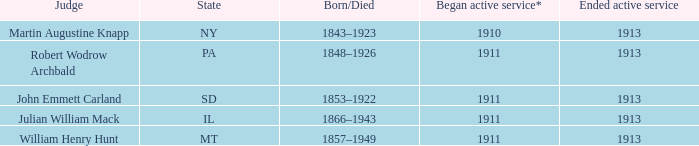Who was the judge for the state SD? John Emmett Carland. 